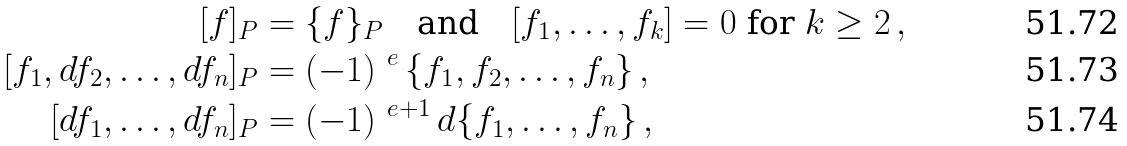Convert formula to latex. <formula><loc_0><loc_0><loc_500><loc_500>[ f ] _ { P } & = \{ f \} _ { P } \quad \text {and} \quad [ f _ { 1 } , \dots , f _ { k } ] = 0 \ \text {for $k\geq 2$} \, , \\ [ f _ { 1 } , d f _ { 2 } , \dots , d f _ { n } ] _ { P } & = ( - 1 ) ^ { \ e } \, \{ f _ { 1 } , f _ { 2 } , \dots , f _ { n } \} \, , \\ [ d f _ { 1 } , \dots , d f _ { n } ] _ { P } & = ( - 1 ) ^ { \ e + 1 } \, d \{ f _ { 1 } , \dots , f _ { n } \} \, ,</formula> 